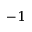Convert formula to latex. <formula><loc_0><loc_0><loc_500><loc_500>^ { - 1 }</formula> 